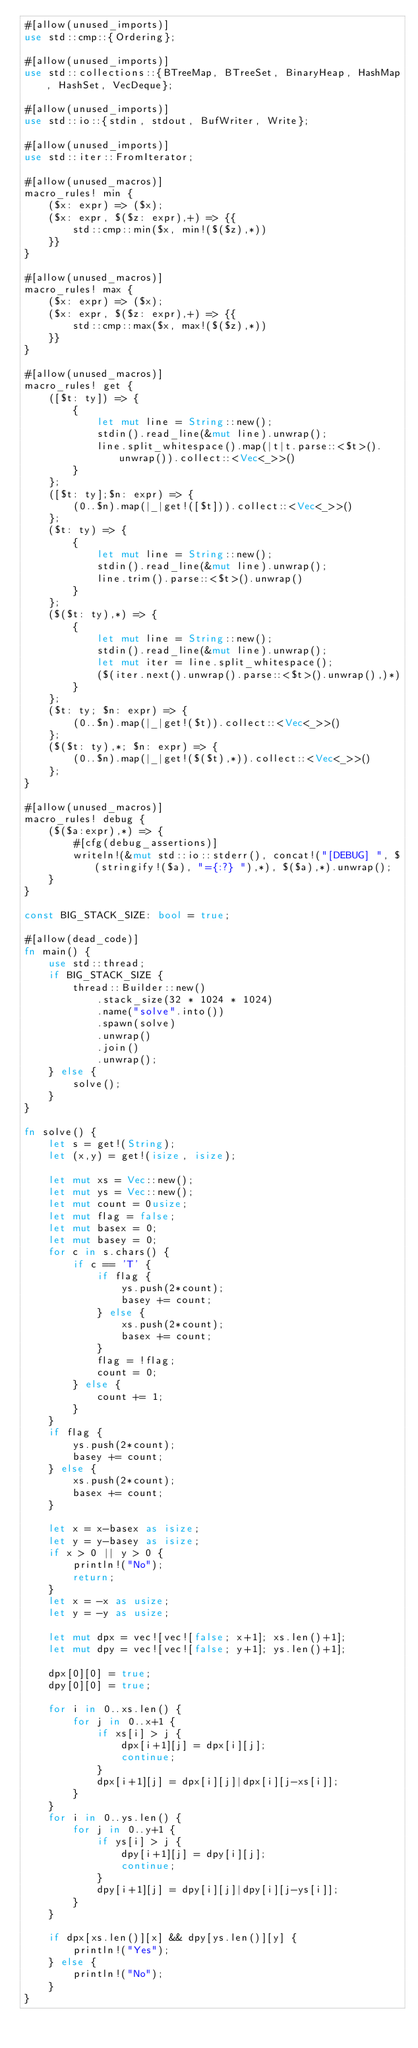<code> <loc_0><loc_0><loc_500><loc_500><_Rust_>#[allow(unused_imports)]
use std::cmp::{Ordering};

#[allow(unused_imports)]
use std::collections::{BTreeMap, BTreeSet, BinaryHeap, HashMap, HashSet, VecDeque};

#[allow(unused_imports)]
use std::io::{stdin, stdout, BufWriter, Write};

#[allow(unused_imports)]
use std::iter::FromIterator;

#[allow(unused_macros)]
macro_rules! min {
    ($x: expr) => ($x);
    ($x: expr, $($z: expr),+) => {{
        std::cmp::min($x, min!($($z),*))
    }}
}

#[allow(unused_macros)]
macro_rules! max {
    ($x: expr) => ($x);
    ($x: expr, $($z: expr),+) => {{
        std::cmp::max($x, max!($($z),*))
    }}
}

#[allow(unused_macros)]
macro_rules! get { 
    ([$t: ty]) => { 
        { 
            let mut line = String::new(); 
            stdin().read_line(&mut line).unwrap(); 
            line.split_whitespace().map(|t|t.parse::<$t>().unwrap()).collect::<Vec<_>>()
        }
    };
    ([$t: ty];$n: expr) => {
        (0..$n).map(|_|get!([$t])).collect::<Vec<_>>()
    };
    ($t: ty) => {
        {
            let mut line = String::new();
            stdin().read_line(&mut line).unwrap();
            line.trim().parse::<$t>().unwrap()
        }
    };
    ($($t: ty),*) => {
        { 
            let mut line = String::new();
            stdin().read_line(&mut line).unwrap();
            let mut iter = line.split_whitespace();
            ($(iter.next().unwrap().parse::<$t>().unwrap(),)*)
        }
    };
    ($t: ty; $n: expr) => {
        (0..$n).map(|_|get!($t)).collect::<Vec<_>>()
    };
    ($($t: ty),*; $n: expr) => {
        (0..$n).map(|_|get!($($t),*)).collect::<Vec<_>>()
    };
}

#[allow(unused_macros)]
macro_rules! debug {
    ($($a:expr),*) => {
        #[cfg(debug_assertions)]
        writeln!(&mut std::io::stderr(), concat!("[DEBUG] ", $(stringify!($a), "={:?} "),*), $($a),*).unwrap();
    }
}

const BIG_STACK_SIZE: bool = true;

#[allow(dead_code)]
fn main() {
    use std::thread;
    if BIG_STACK_SIZE {
        thread::Builder::new()
            .stack_size(32 * 1024 * 1024)
            .name("solve".into())
            .spawn(solve)
            .unwrap()
            .join()
            .unwrap();
    } else {
        solve();
    }
}

fn solve() {
    let s = get!(String);
    let (x,y) = get!(isize, isize);

    let mut xs = Vec::new();
    let mut ys = Vec::new();
    let mut count = 0usize;
    let mut flag = false;
    let mut basex = 0;
    let mut basey = 0;
    for c in s.chars() {
        if c == 'T' {
            if flag {
                ys.push(2*count);
                basey += count;
            } else {
                xs.push(2*count);
                basex += count;
            }
            flag = !flag;
            count = 0;
        } else {
            count += 1;
        }
    }
    if flag {
        ys.push(2*count);
        basey += count;
    } else {
        xs.push(2*count);
        basex += count;
    }

    let x = x-basex as isize;
    let y = y-basey as isize;
    if x > 0 || y > 0 {
        println!("No");
        return;
    }
    let x = -x as usize;
    let y = -y as usize;

    let mut dpx = vec![vec![false; x+1]; xs.len()+1];
    let mut dpy = vec![vec![false; y+1]; ys.len()+1];

    dpx[0][0] = true;
    dpy[0][0] = true;

    for i in 0..xs.len() {
        for j in 0..x+1 {
            if xs[i] > j {
                dpx[i+1][j] = dpx[i][j];
                continue;
            }
            dpx[i+1][j] = dpx[i][j]|dpx[i][j-xs[i]];
        }
    }
    for i in 0..ys.len() {
        for j in 0..y+1 {
            if ys[i] > j {
                dpy[i+1][j] = dpy[i][j];
                continue;
            }
            dpy[i+1][j] = dpy[i][j]|dpy[i][j-ys[i]];
        }
    }

    if dpx[xs.len()][x] && dpy[ys.len()][y] {
        println!("Yes");
    } else {
        println!("No");
    }
}
</code> 